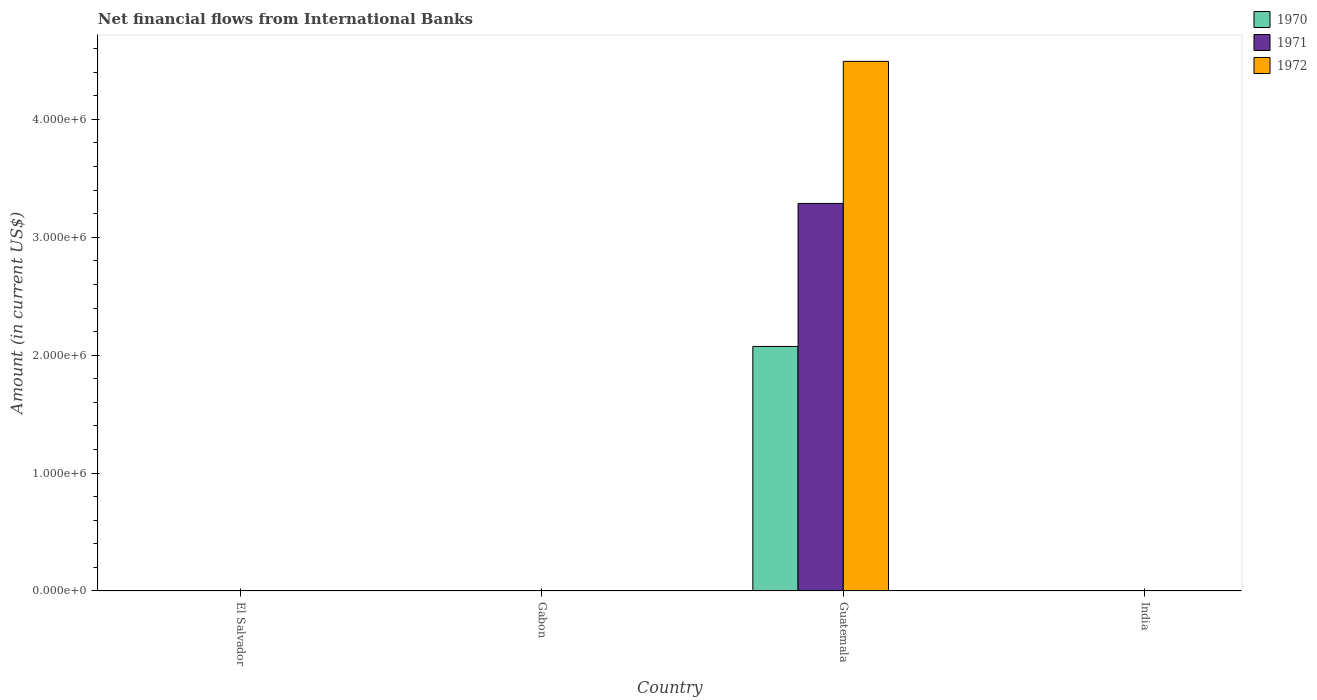How many different coloured bars are there?
Ensure brevity in your answer.  3. Are the number of bars per tick equal to the number of legend labels?
Ensure brevity in your answer.  No. Are the number of bars on each tick of the X-axis equal?
Offer a terse response. No. How many bars are there on the 4th tick from the left?
Ensure brevity in your answer.  0. What is the label of the 4th group of bars from the left?
Keep it short and to the point. India. What is the net financial aid flows in 1970 in Guatemala?
Make the answer very short. 2.07e+06. Across all countries, what is the maximum net financial aid flows in 1972?
Keep it short and to the point. 4.49e+06. Across all countries, what is the minimum net financial aid flows in 1971?
Provide a succinct answer. 0. In which country was the net financial aid flows in 1970 maximum?
Keep it short and to the point. Guatemala. What is the total net financial aid flows in 1971 in the graph?
Ensure brevity in your answer.  3.29e+06. What is the difference between the net financial aid flows in 1972 in Guatemala and the net financial aid flows in 1971 in El Salvador?
Provide a short and direct response. 4.49e+06. What is the average net financial aid flows in 1972 per country?
Your answer should be compact. 1.12e+06. What is the difference between the net financial aid flows of/in 1972 and net financial aid flows of/in 1970 in Guatemala?
Your answer should be very brief. 2.42e+06. In how many countries, is the net financial aid flows in 1972 greater than 4400000 US$?
Provide a succinct answer. 1. What is the difference between the highest and the lowest net financial aid flows in 1972?
Your answer should be compact. 4.49e+06. In how many countries, is the net financial aid flows in 1970 greater than the average net financial aid flows in 1970 taken over all countries?
Ensure brevity in your answer.  1. How many bars are there?
Provide a short and direct response. 3. Are all the bars in the graph horizontal?
Offer a terse response. No. How many countries are there in the graph?
Your answer should be compact. 4. Does the graph contain any zero values?
Keep it short and to the point. Yes. Where does the legend appear in the graph?
Your answer should be very brief. Top right. What is the title of the graph?
Your response must be concise. Net financial flows from International Banks. Does "2007" appear as one of the legend labels in the graph?
Provide a short and direct response. No. What is the label or title of the X-axis?
Your response must be concise. Country. What is the label or title of the Y-axis?
Give a very brief answer. Amount (in current US$). What is the Amount (in current US$) in 1970 in El Salvador?
Provide a short and direct response. 0. What is the Amount (in current US$) of 1971 in El Salvador?
Ensure brevity in your answer.  0. What is the Amount (in current US$) in 1970 in Guatemala?
Offer a terse response. 2.07e+06. What is the Amount (in current US$) of 1971 in Guatemala?
Keep it short and to the point. 3.29e+06. What is the Amount (in current US$) in 1972 in Guatemala?
Provide a short and direct response. 4.49e+06. What is the Amount (in current US$) of 1970 in India?
Give a very brief answer. 0. What is the Amount (in current US$) in 1971 in India?
Provide a short and direct response. 0. What is the Amount (in current US$) in 1972 in India?
Offer a very short reply. 0. Across all countries, what is the maximum Amount (in current US$) in 1970?
Keep it short and to the point. 2.07e+06. Across all countries, what is the maximum Amount (in current US$) of 1971?
Your answer should be compact. 3.29e+06. Across all countries, what is the maximum Amount (in current US$) in 1972?
Keep it short and to the point. 4.49e+06. Across all countries, what is the minimum Amount (in current US$) of 1970?
Make the answer very short. 0. Across all countries, what is the minimum Amount (in current US$) of 1971?
Provide a succinct answer. 0. What is the total Amount (in current US$) in 1970 in the graph?
Offer a terse response. 2.07e+06. What is the total Amount (in current US$) of 1971 in the graph?
Provide a succinct answer. 3.29e+06. What is the total Amount (in current US$) in 1972 in the graph?
Provide a succinct answer. 4.49e+06. What is the average Amount (in current US$) in 1970 per country?
Give a very brief answer. 5.18e+05. What is the average Amount (in current US$) of 1971 per country?
Offer a very short reply. 8.22e+05. What is the average Amount (in current US$) of 1972 per country?
Make the answer very short. 1.12e+06. What is the difference between the Amount (in current US$) in 1970 and Amount (in current US$) in 1971 in Guatemala?
Your response must be concise. -1.21e+06. What is the difference between the Amount (in current US$) of 1970 and Amount (in current US$) of 1972 in Guatemala?
Your answer should be very brief. -2.42e+06. What is the difference between the Amount (in current US$) in 1971 and Amount (in current US$) in 1972 in Guatemala?
Provide a short and direct response. -1.20e+06. What is the difference between the highest and the lowest Amount (in current US$) in 1970?
Provide a short and direct response. 2.07e+06. What is the difference between the highest and the lowest Amount (in current US$) of 1971?
Offer a terse response. 3.29e+06. What is the difference between the highest and the lowest Amount (in current US$) of 1972?
Provide a short and direct response. 4.49e+06. 